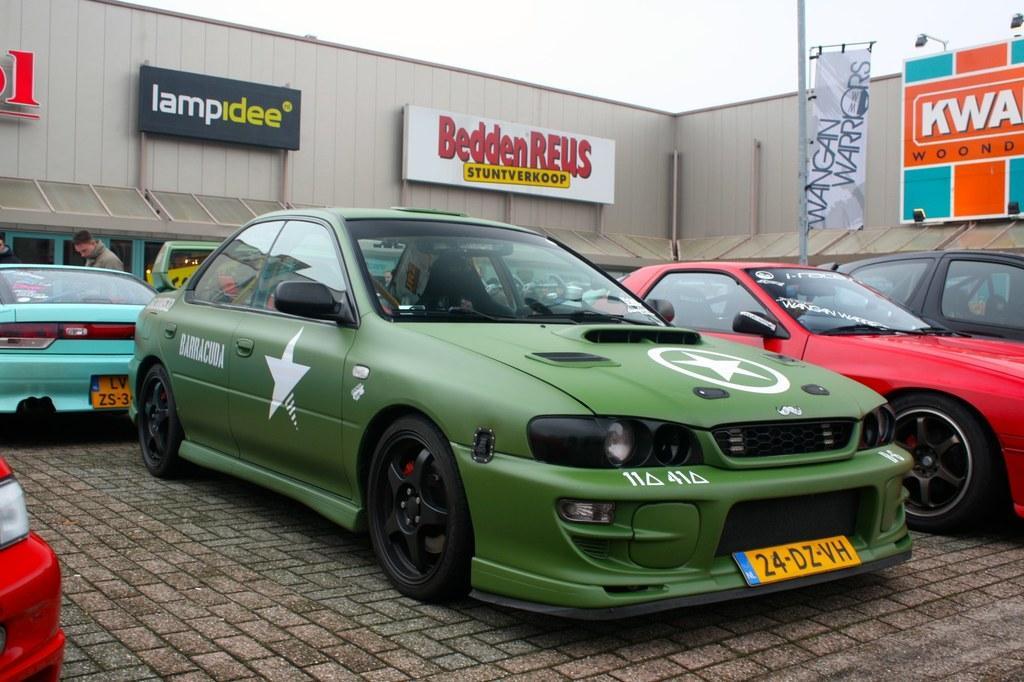Describe this image in one or two sentences. In this picture there are cars in the image and there are posters in the image and there is a flag on the pole on the right side of the image and there is a man at the top side of the image in front of a car. 